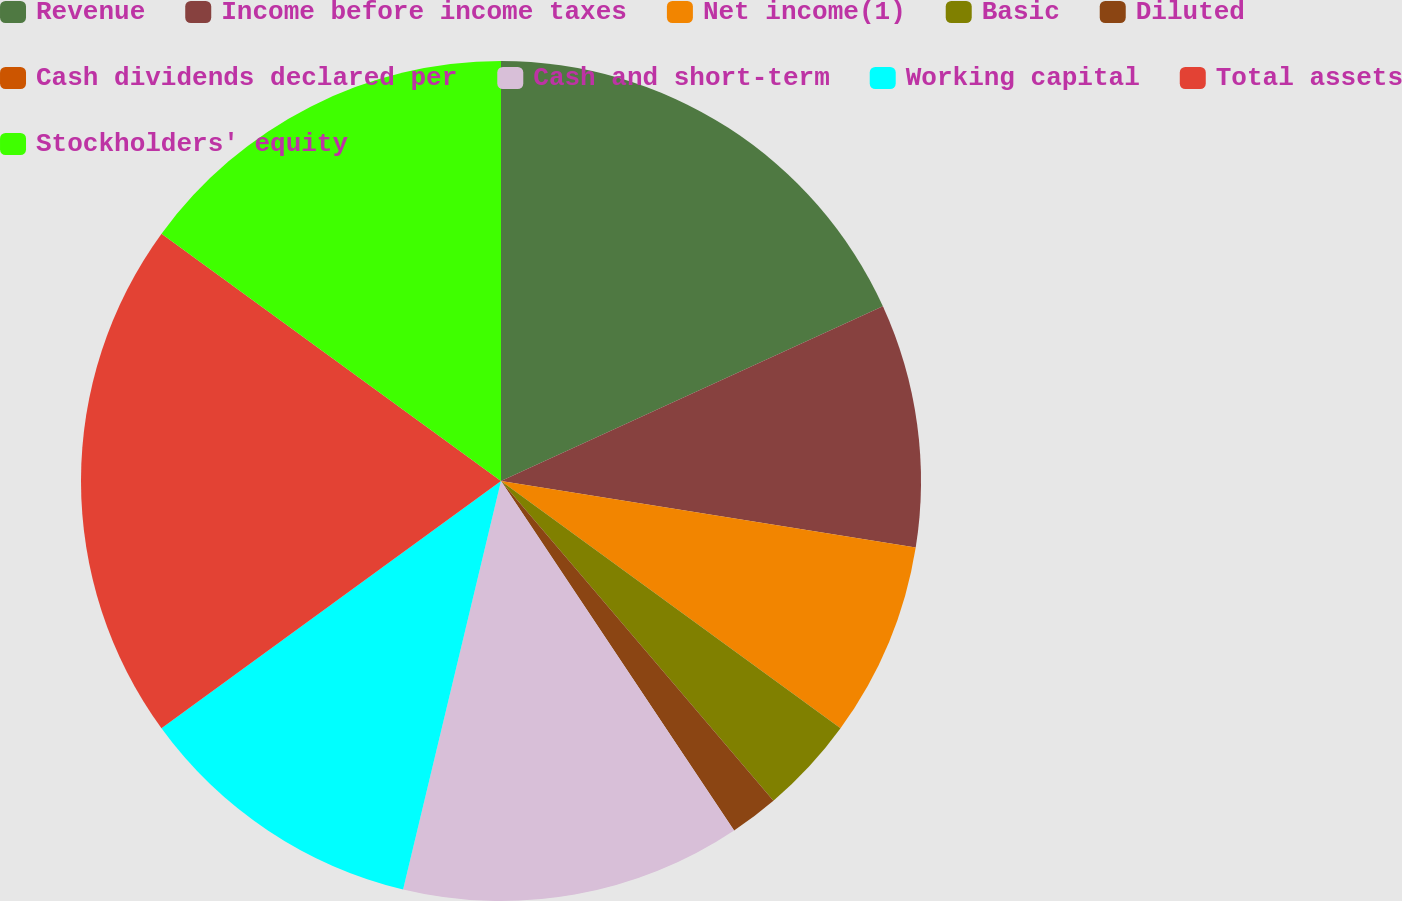<chart> <loc_0><loc_0><loc_500><loc_500><pie_chart><fcel>Revenue<fcel>Income before income taxes<fcel>Net income(1)<fcel>Basic<fcel>Diluted<fcel>Cash dividends declared per<fcel>Cash and short-term<fcel>Working capital<fcel>Total assets<fcel>Stockholders' equity<nl><fcel>18.17%<fcel>9.36%<fcel>7.49%<fcel>3.75%<fcel>1.87%<fcel>0.0%<fcel>13.11%<fcel>11.24%<fcel>20.04%<fcel>14.98%<nl></chart> 